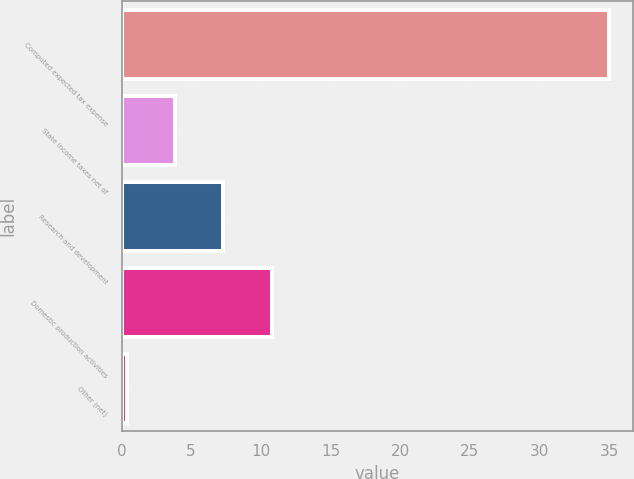<chart> <loc_0><loc_0><loc_500><loc_500><bar_chart><fcel>Computed expected tax expense<fcel>State income taxes net of<fcel>Research and development<fcel>Domestic production activities<fcel>Other (net)<nl><fcel>35<fcel>3.86<fcel>7.32<fcel>10.78<fcel>0.4<nl></chart> 